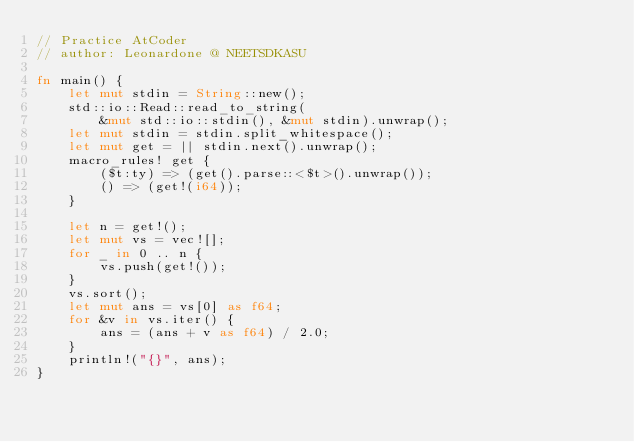<code> <loc_0><loc_0><loc_500><loc_500><_Rust_>// Practice AtCoder
// author: Leonardone @ NEETSDKASU

fn main() {
    let mut stdin = String::new();
    std::io::Read::read_to_string(
        &mut std::io::stdin(), &mut stdin).unwrap();
    let mut stdin = stdin.split_whitespace();
    let mut get = || stdin.next().unwrap();
    macro_rules! get {
        ($t:ty) => (get().parse::<$t>().unwrap());
        () => (get!(i64));
    }
    
    let n = get!();
    let mut vs = vec![];
    for _ in 0 .. n {
        vs.push(get!());
    }
    vs.sort();
    let mut ans = vs[0] as f64;
    for &v in vs.iter() {
        ans = (ans + v as f64) / 2.0;
    }
    println!("{}", ans);
}</code> 